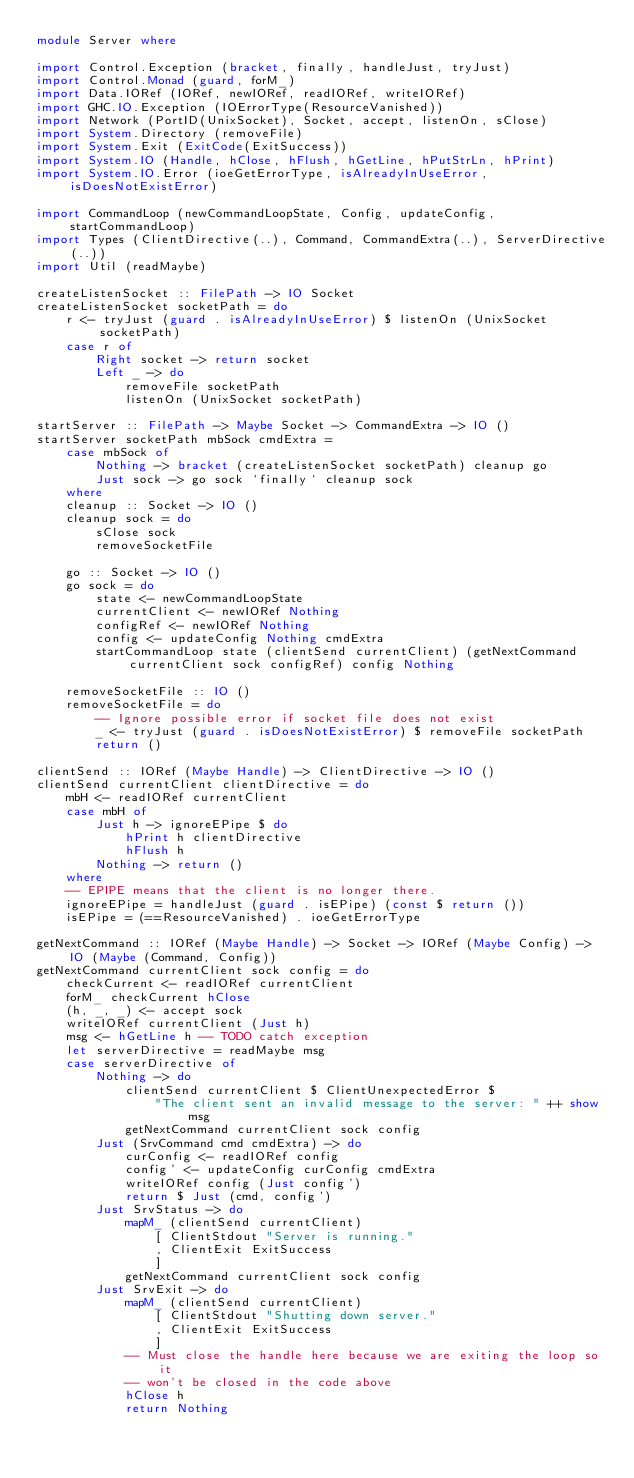Convert code to text. <code><loc_0><loc_0><loc_500><loc_500><_Haskell_>module Server where

import Control.Exception (bracket, finally, handleJust, tryJust)
import Control.Monad (guard, forM_)
import Data.IORef (IORef, newIORef, readIORef, writeIORef)
import GHC.IO.Exception (IOErrorType(ResourceVanished))
import Network (PortID(UnixSocket), Socket, accept, listenOn, sClose)
import System.Directory (removeFile)
import System.Exit (ExitCode(ExitSuccess))
import System.IO (Handle, hClose, hFlush, hGetLine, hPutStrLn, hPrint)
import System.IO.Error (ioeGetErrorType, isAlreadyInUseError, isDoesNotExistError)

import CommandLoop (newCommandLoopState, Config, updateConfig, startCommandLoop)
import Types (ClientDirective(..), Command, CommandExtra(..), ServerDirective(..))
import Util (readMaybe)

createListenSocket :: FilePath -> IO Socket
createListenSocket socketPath = do
    r <- tryJust (guard . isAlreadyInUseError) $ listenOn (UnixSocket socketPath)
    case r of
        Right socket -> return socket
        Left _ -> do
            removeFile socketPath
            listenOn (UnixSocket socketPath)

startServer :: FilePath -> Maybe Socket -> CommandExtra -> IO ()
startServer socketPath mbSock cmdExtra = 
    case mbSock of
        Nothing -> bracket (createListenSocket socketPath) cleanup go
        Just sock -> go sock `finally` cleanup sock
    where
    cleanup :: Socket -> IO ()
    cleanup sock = do
        sClose sock
        removeSocketFile

    go :: Socket -> IO ()
    go sock = do
        state <- newCommandLoopState
        currentClient <- newIORef Nothing
        configRef <- newIORef Nothing
        config <- updateConfig Nothing cmdExtra
        startCommandLoop state (clientSend currentClient) (getNextCommand currentClient sock configRef) config Nothing

    removeSocketFile :: IO ()
    removeSocketFile = do
        -- Ignore possible error if socket file does not exist
        _ <- tryJust (guard . isDoesNotExistError) $ removeFile socketPath
        return ()

clientSend :: IORef (Maybe Handle) -> ClientDirective -> IO ()
clientSend currentClient clientDirective = do
    mbH <- readIORef currentClient
    case mbH of
        Just h -> ignoreEPipe $ do
            hPrint h clientDirective
            hFlush h
        Nothing -> return ()
    where
    -- EPIPE means that the client is no longer there.
    ignoreEPipe = handleJust (guard . isEPipe) (const $ return ())
    isEPipe = (==ResourceVanished) . ioeGetErrorType

getNextCommand :: IORef (Maybe Handle) -> Socket -> IORef (Maybe Config) -> IO (Maybe (Command, Config))
getNextCommand currentClient sock config = do
    checkCurrent <- readIORef currentClient
    forM_ checkCurrent hClose
    (h, _, _) <- accept sock
    writeIORef currentClient (Just h)
    msg <- hGetLine h -- TODO catch exception
    let serverDirective = readMaybe msg
    case serverDirective of
        Nothing -> do
            clientSend currentClient $ ClientUnexpectedError $
                "The client sent an invalid message to the server: " ++ show msg
            getNextCommand currentClient sock config
        Just (SrvCommand cmd cmdExtra) -> do
            curConfig <- readIORef config
            config' <- updateConfig curConfig cmdExtra
            writeIORef config (Just config')
            return $ Just (cmd, config')
        Just SrvStatus -> do
            mapM_ (clientSend currentClient)
                [ ClientStdout "Server is running."
                , ClientExit ExitSuccess
                ]
            getNextCommand currentClient sock config
        Just SrvExit -> do
            mapM_ (clientSend currentClient)
                [ ClientStdout "Shutting down server."
                , ClientExit ExitSuccess
                ]
            -- Must close the handle here because we are exiting the loop so it
            -- won't be closed in the code above
            hClose h
            return Nothing
</code> 